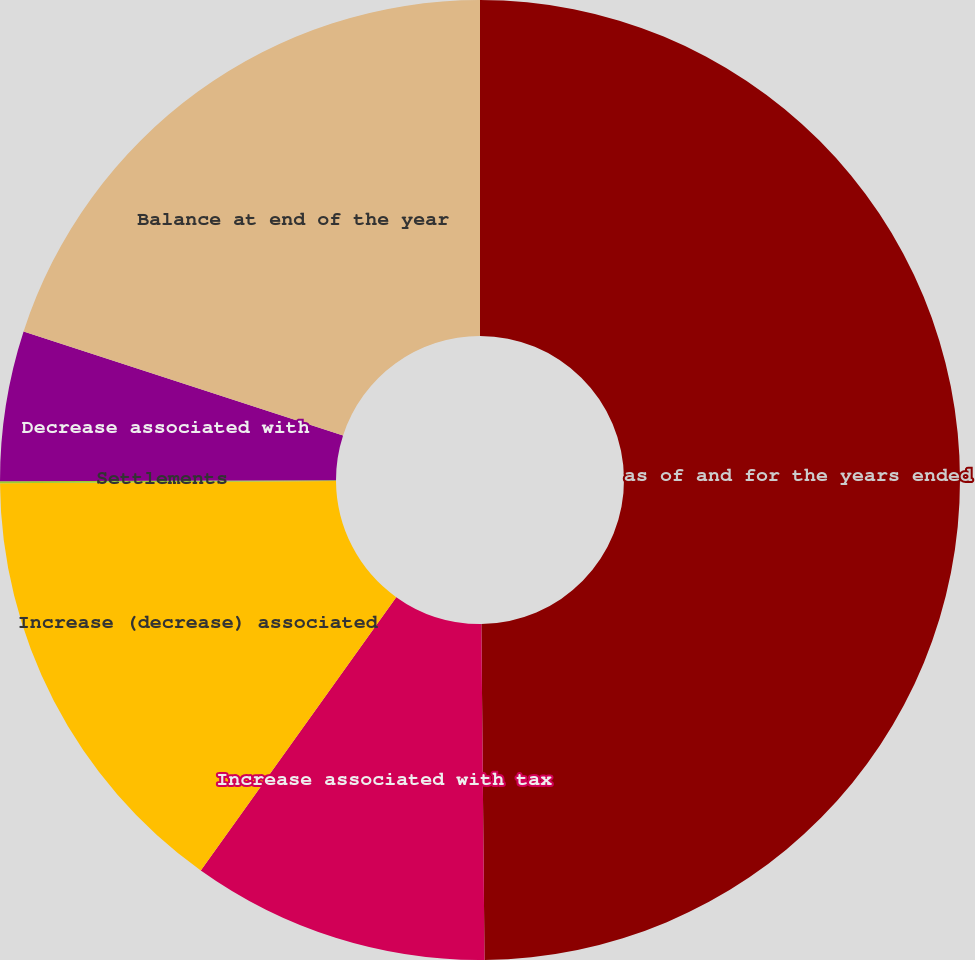Convert chart. <chart><loc_0><loc_0><loc_500><loc_500><pie_chart><fcel>as of and for the years ended<fcel>Increase associated with tax<fcel>Increase (decrease) associated<fcel>Settlements<fcel>Decrease associated with<fcel>Balance at end of the year<nl><fcel>49.85%<fcel>10.03%<fcel>15.01%<fcel>0.07%<fcel>5.05%<fcel>19.99%<nl></chart> 